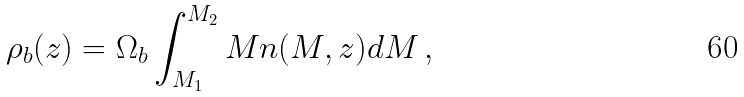<formula> <loc_0><loc_0><loc_500><loc_500>\rho _ { b } ( z ) = \Omega _ { b } \int _ { M _ { 1 } } ^ { M _ { 2 } } M n ( M , z ) d M \, ,</formula> 